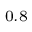<formula> <loc_0><loc_0><loc_500><loc_500>_ { 0 . 8 }</formula> 